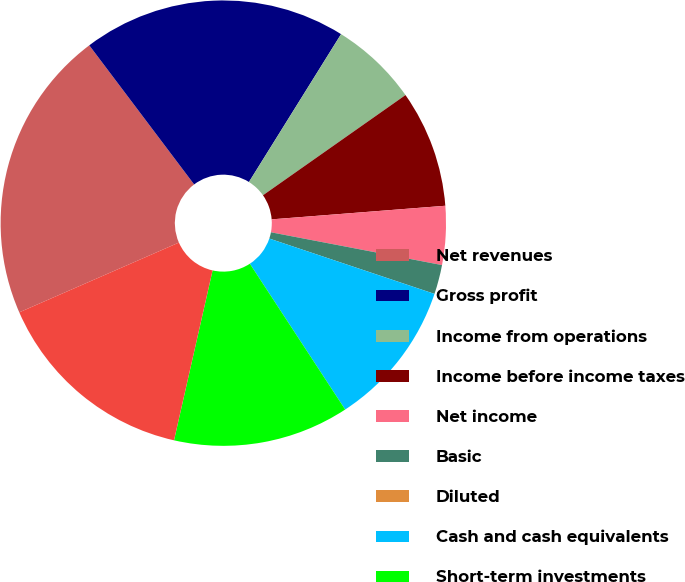Convert chart to OTSL. <chart><loc_0><loc_0><loc_500><loc_500><pie_chart><fcel>Net revenues<fcel>Gross profit<fcel>Income from operations<fcel>Income before income taxes<fcel>Net income<fcel>Basic<fcel>Diluted<fcel>Cash and cash equivalents<fcel>Short-term investments<fcel>Long-term investments<nl><fcel>21.28%<fcel>19.15%<fcel>6.38%<fcel>8.51%<fcel>4.26%<fcel>2.13%<fcel>0.0%<fcel>10.64%<fcel>12.77%<fcel>14.89%<nl></chart> 